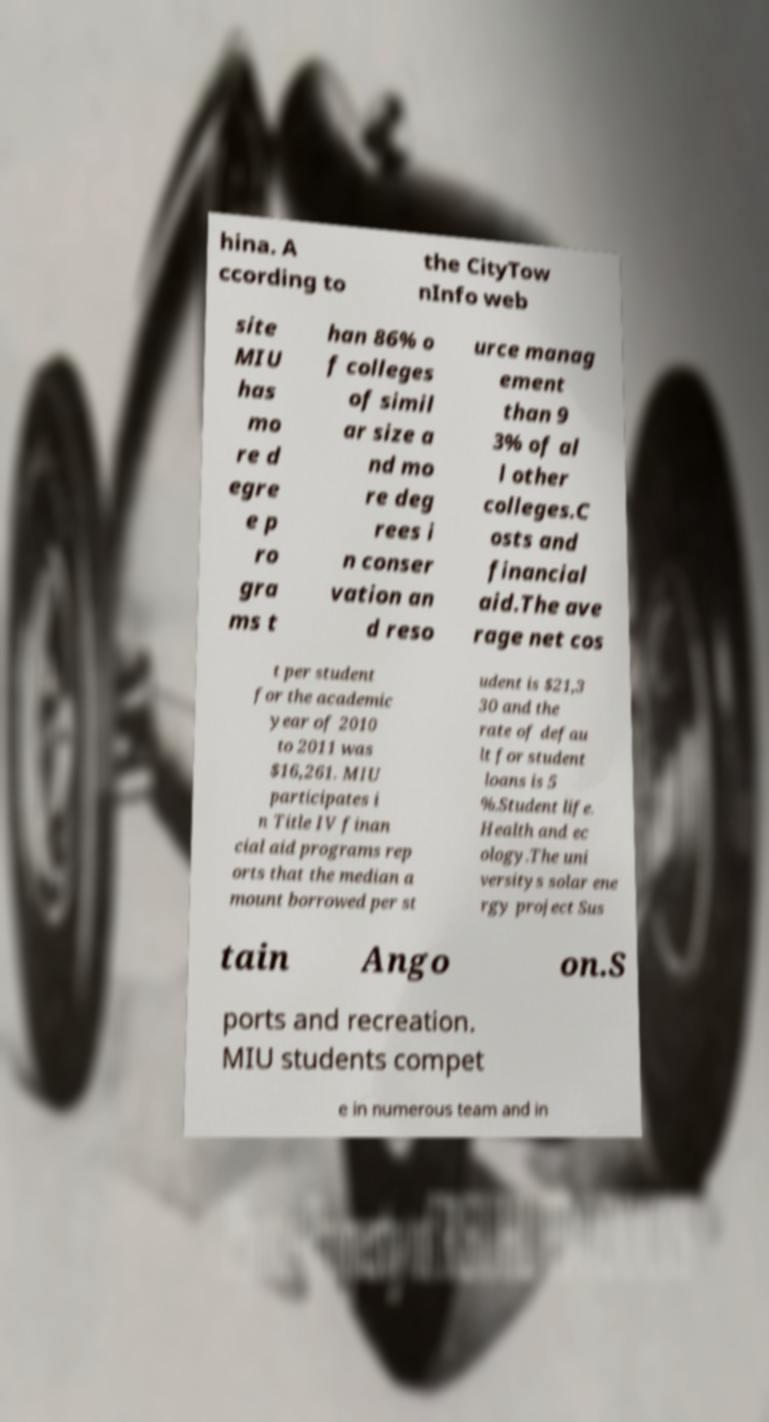Please identify and transcribe the text found in this image. hina. A ccording to the CityTow nInfo web site MIU has mo re d egre e p ro gra ms t han 86% o f colleges of simil ar size a nd mo re deg rees i n conser vation an d reso urce manag ement than 9 3% of al l other colleges.C osts and financial aid.The ave rage net cos t per student for the academic year of 2010 to 2011 was $16,261. MIU participates i n Title IV finan cial aid programs rep orts that the median a mount borrowed per st udent is $21,3 30 and the rate of defau lt for student loans is 5 %.Student life. Health and ec ology.The uni versitys solar ene rgy project Sus tain Ango on.S ports and recreation. MIU students compet e in numerous team and in 